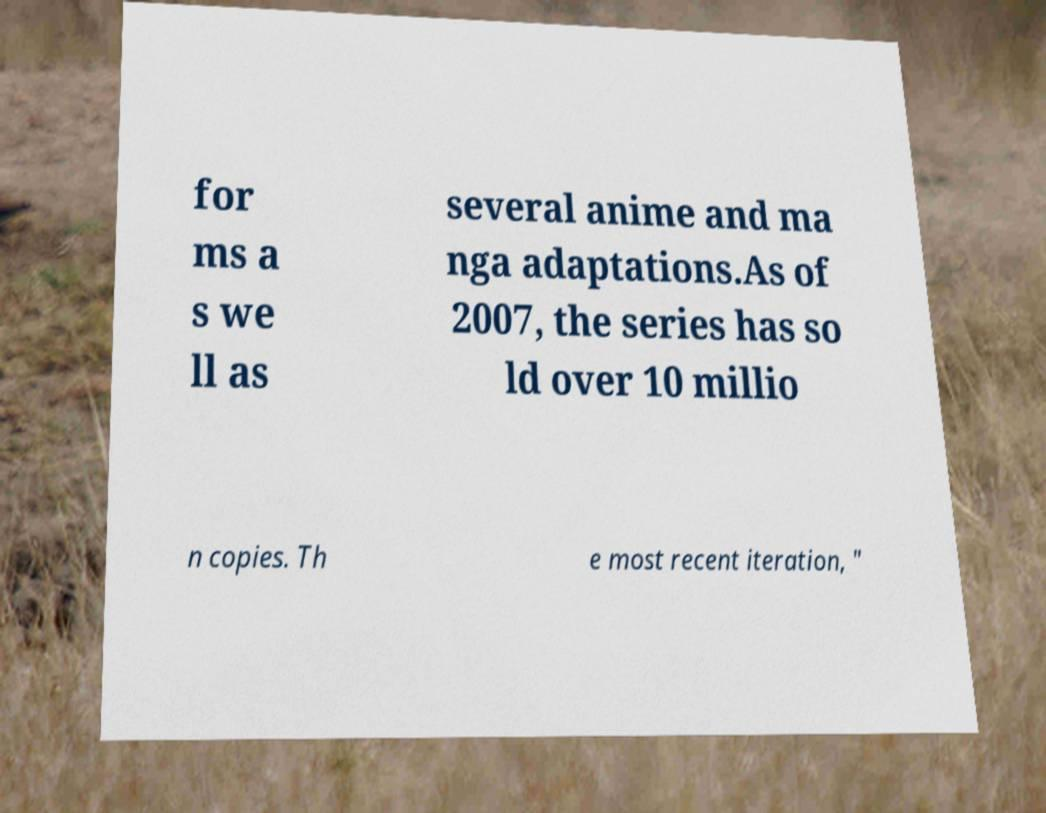Please identify and transcribe the text found in this image. for ms a s we ll as several anime and ma nga adaptations.As of 2007, the series has so ld over 10 millio n copies. Th e most recent iteration, " 